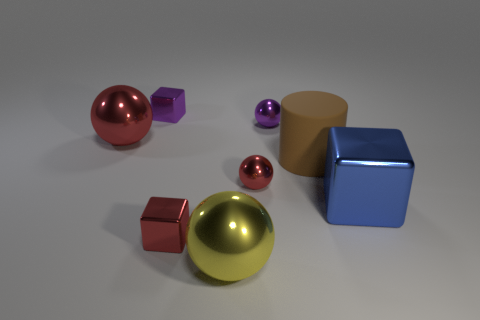If these objects were part of a game, what kind of game could it be? If these objects were part of a game, it could be a sorting or categorization game where players are challenged to group objects by color, shape, or size. Alternatively, they could be game pieces in a tabletop strategy game where each shape corresponds to a different role or power. 